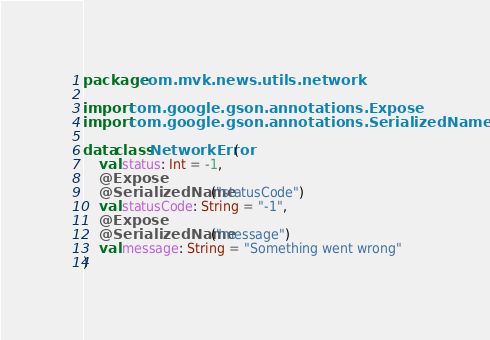Convert code to text. <code><loc_0><loc_0><loc_500><loc_500><_Kotlin_>package com.mvk.news.utils.network

import com.google.gson.annotations.Expose
import com.google.gson.annotations.SerializedName

data class NetworkError(
    val status: Int = -1,
    @Expose
    @SerializedName("statusCode")
    val statusCode: String = "-1",
    @Expose
    @SerializedName("message")
    val message: String = "Something went wrong"
)</code> 